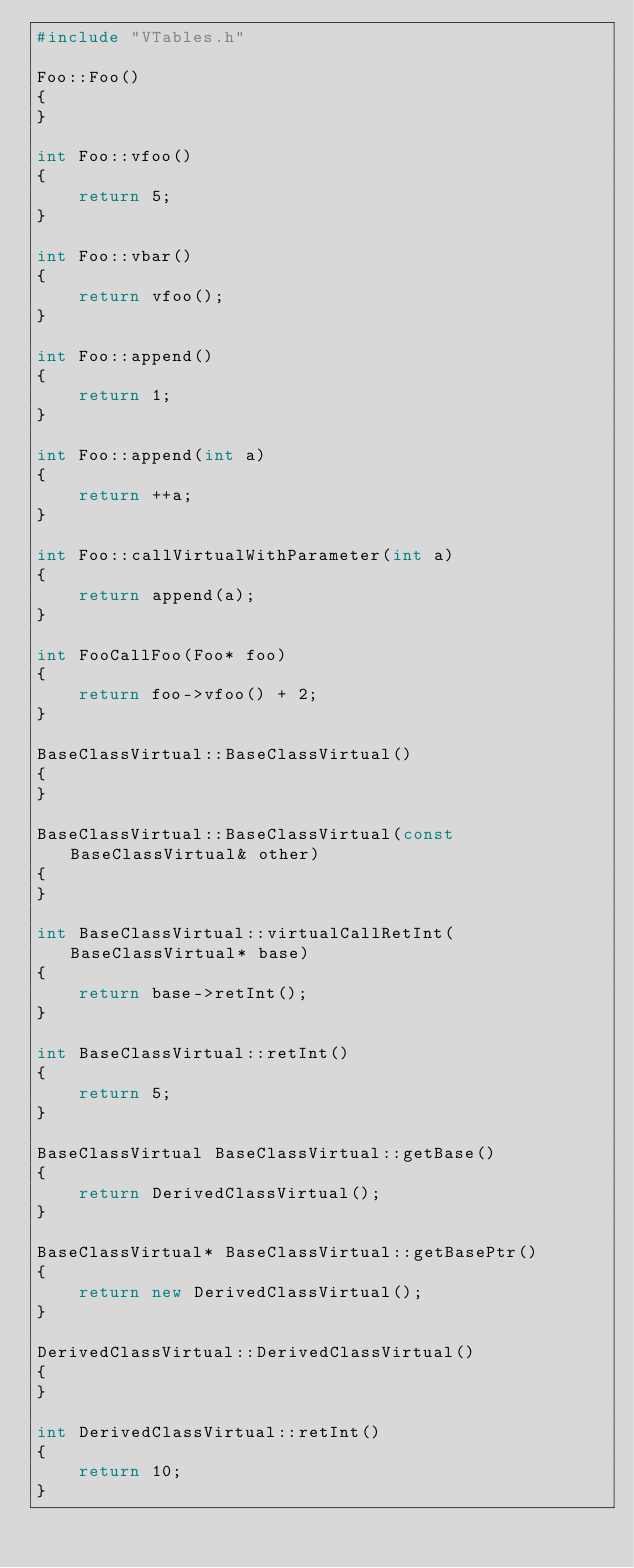<code> <loc_0><loc_0><loc_500><loc_500><_C++_>#include "VTables.h"

Foo::Foo()
{
}

int Foo::vfoo()
{
    return 5;
}

int Foo::vbar()
{
    return vfoo();
}

int Foo::append()
{
    return 1;
}

int Foo::append(int a)
{
    return ++a;
}

int Foo::callVirtualWithParameter(int a)
{
    return append(a);
}

int FooCallFoo(Foo* foo)
{
    return foo->vfoo() + 2;
}

BaseClassVirtual::BaseClassVirtual()
{
}

BaseClassVirtual::BaseClassVirtual(const BaseClassVirtual& other)
{
}

int BaseClassVirtual::virtualCallRetInt(BaseClassVirtual* base)
{
    return base->retInt();
}

int BaseClassVirtual::retInt()
{
    return 5;
}

BaseClassVirtual BaseClassVirtual::getBase()
{
    return DerivedClassVirtual();
}

BaseClassVirtual* BaseClassVirtual::getBasePtr()
{
    return new DerivedClassVirtual();
}

DerivedClassVirtual::DerivedClassVirtual()
{
}

int DerivedClassVirtual::retInt()
{
    return 10;
}

</code> 